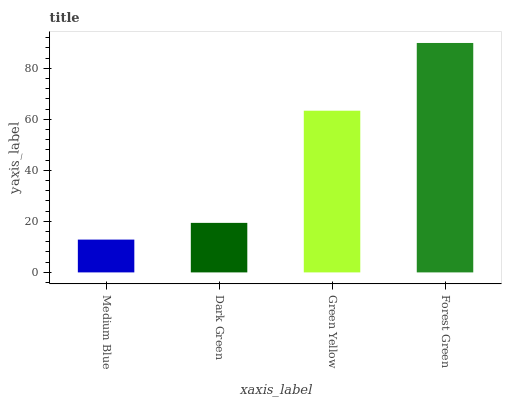Is Medium Blue the minimum?
Answer yes or no. Yes. Is Forest Green the maximum?
Answer yes or no. Yes. Is Dark Green the minimum?
Answer yes or no. No. Is Dark Green the maximum?
Answer yes or no. No. Is Dark Green greater than Medium Blue?
Answer yes or no. Yes. Is Medium Blue less than Dark Green?
Answer yes or no. Yes. Is Medium Blue greater than Dark Green?
Answer yes or no. No. Is Dark Green less than Medium Blue?
Answer yes or no. No. Is Green Yellow the high median?
Answer yes or no. Yes. Is Dark Green the low median?
Answer yes or no. Yes. Is Medium Blue the high median?
Answer yes or no. No. Is Forest Green the low median?
Answer yes or no. No. 